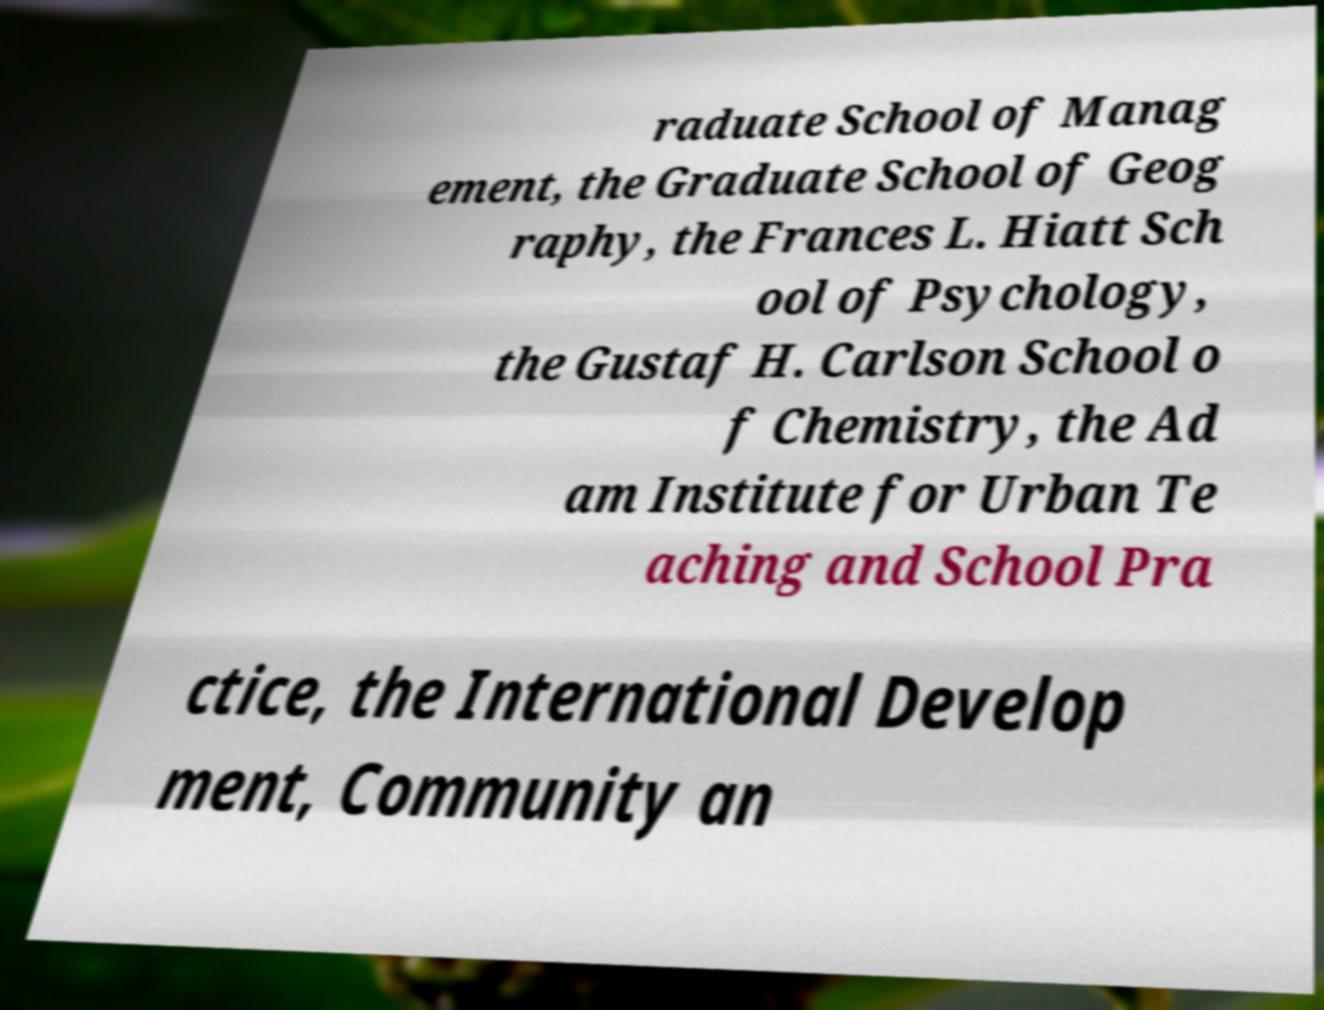What messages or text are displayed in this image? I need them in a readable, typed format. raduate School of Manag ement, the Graduate School of Geog raphy, the Frances L. Hiatt Sch ool of Psychology, the Gustaf H. Carlson School o f Chemistry, the Ad am Institute for Urban Te aching and School Pra ctice, the International Develop ment, Community an 